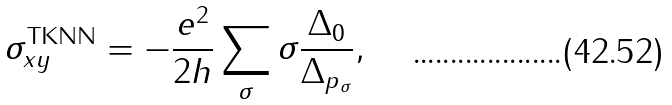<formula> <loc_0><loc_0><loc_500><loc_500>\sigma _ { x y } ^ { \text {TKNN} } = - \frac { e ^ { 2 } } { 2 h } \sum _ { \sigma } \sigma \frac { \Delta _ { 0 } } { \Delta _ { p _ { \sigma } } } ,</formula> 